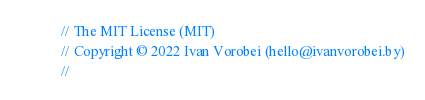<code> <loc_0><loc_0><loc_500><loc_500><_Swift_>// The MIT License (MIT)
// Copyright © 2022 Ivan Vorobei (hello@ivanvorobei.by)
//</code> 